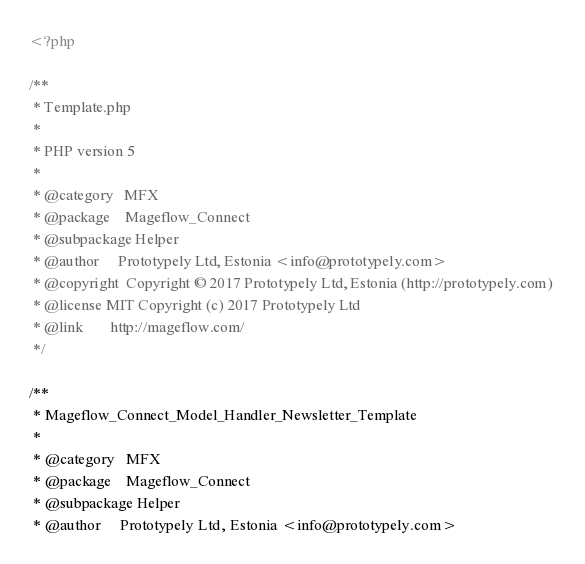Convert code to text. <code><loc_0><loc_0><loc_500><loc_500><_PHP_><?php

/**
 * Template.php
 *
 * PHP version 5
 *
 * @category   MFX
 * @package    Mageflow_Connect
 * @subpackage Helper
 * @author     Prototypely Ltd, Estonia <info@prototypely.com>
 * @copyright  Copyright © 2017 Prototypely Ltd, Estonia (http://prototypely.com) 
 * @license MIT Copyright (c) 2017 Prototypely Ltd
 * @link       http://mageflow.com/
 */

/**
 * Mageflow_Connect_Model_Handler_Newsletter_Template
 *
 * @category   MFX
 * @package    Mageflow_Connect
 * @subpackage Helper
 * @author     Prototypely Ltd, Estonia <info@prototypely.com></code> 